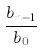Convert formula to latex. <formula><loc_0><loc_0><loc_500><loc_500>\frac { b _ { n - 1 } } { b _ { 0 } }</formula> 